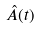Convert formula to latex. <formula><loc_0><loc_0><loc_500><loc_500>\hat { A } ( t )</formula> 